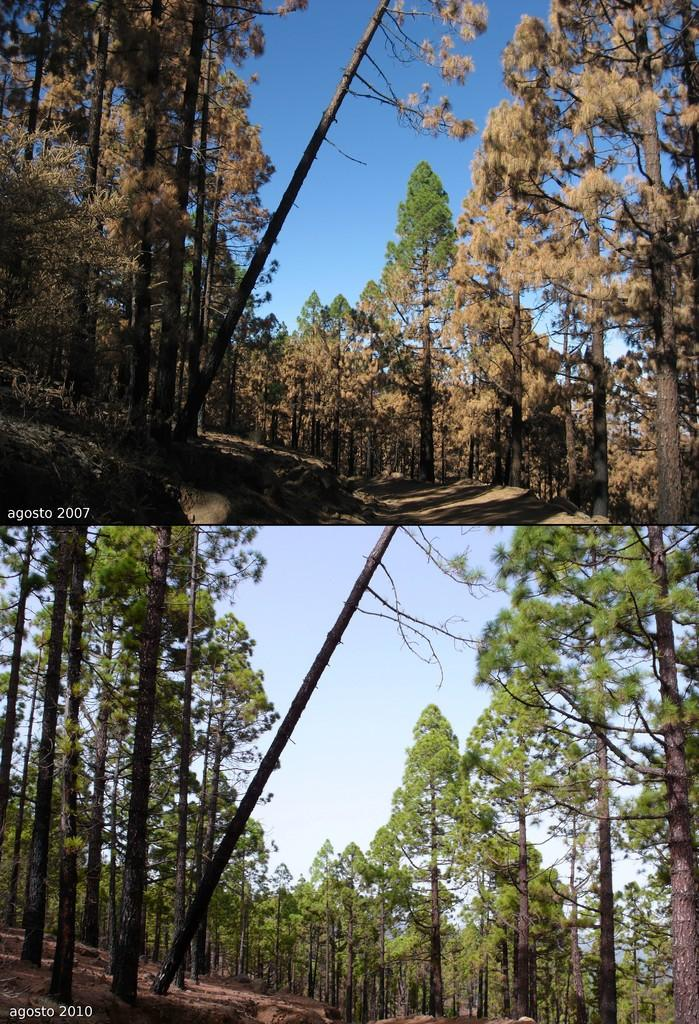What is the composition of the image? The image is a collage of two images. Are the two images in the collage different or the same? Both images are the same. What type of landscape is depicted in the image? There are many trees on the ground in the image. What part of the natural environment is visible in the image? The sky is visible at the top of the image. What type of collar can be seen on the trees in the image? There is no collar present on the trees in the image; they are simply depicted as trees with no additional accessories. 